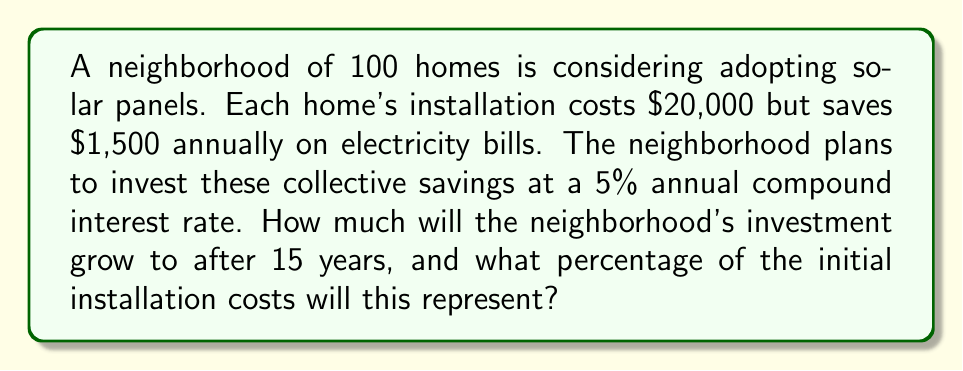Can you solve this math problem? Let's approach this problem step-by-step:

1) First, calculate the total installation cost for the neighborhood:
   $20,000 * 100 homes = $2,000,000

2) Calculate the annual savings for the entire neighborhood:
   $1,500 * 100 homes = $150,000 per year

3) We need to use the compound interest formula to calculate the future value of these savings:
   $$A = P(1 + r)^n$$
   Where:
   A = Final amount
   P = Principal amount (annual savings in this case)
   r = Annual interest rate (as a decimal)
   n = Number of years

4) Plugging in our values:
   $$A = 150,000(1 + 0.05)^{15}$$

5) Calculate:
   $$A = 150,000 * 2.0789 = 3,118,350$$

6) The neighborhood's investment will grow to $3,118,350 after 15 years.

7) To calculate what percentage this represents of the initial installation costs:
   $$(3,118,350 / 2,000,000) * 100 = 155.92\%$$
Answer: $3,118,350; 155.92% 